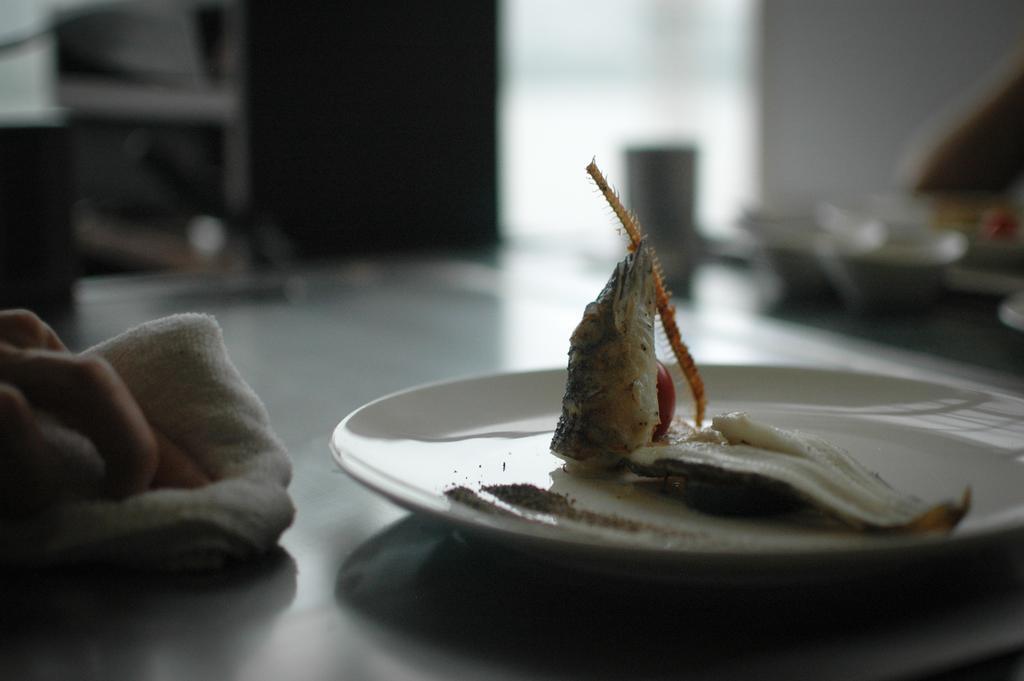Describe this image in one or two sentences. In the foreground of the picture there is a table, on the table there are plate, food item, cloth and a person's hand. The background is blurred. 